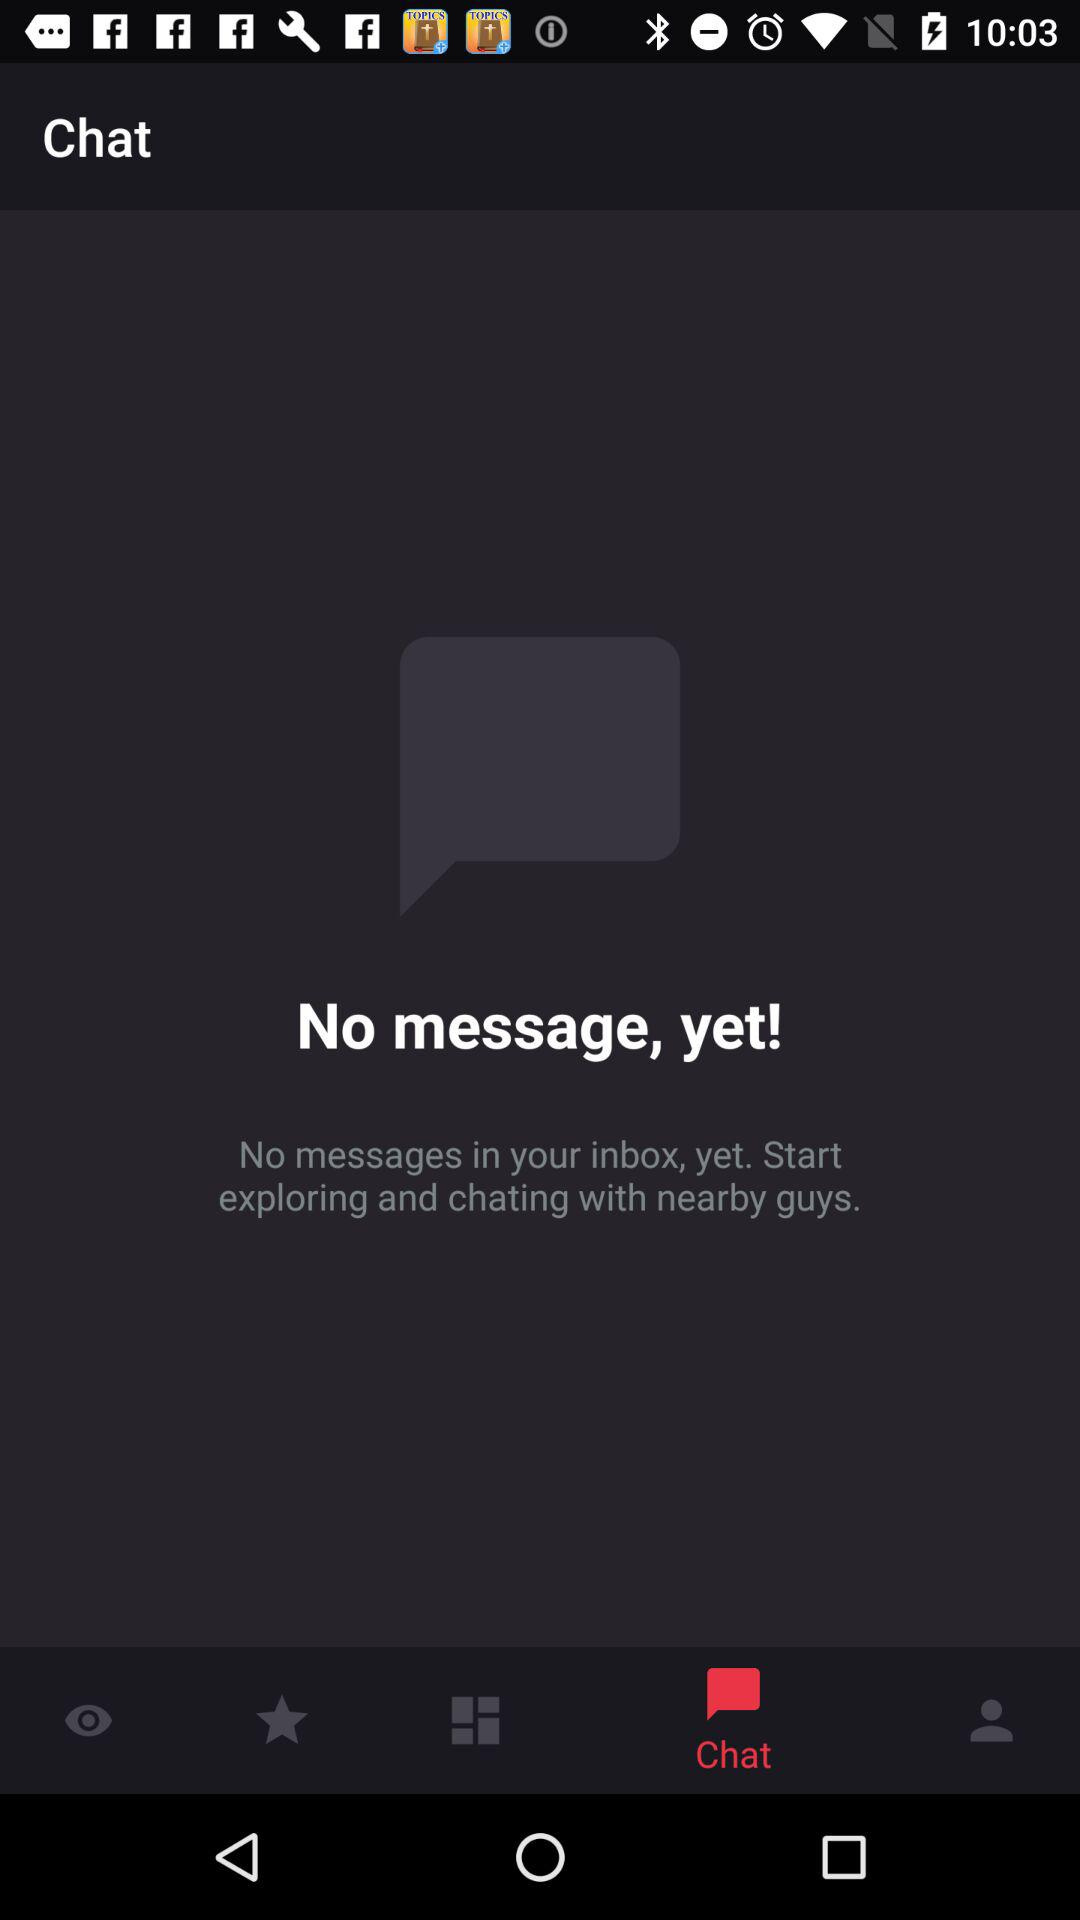Are there any messages? There are no messages. 